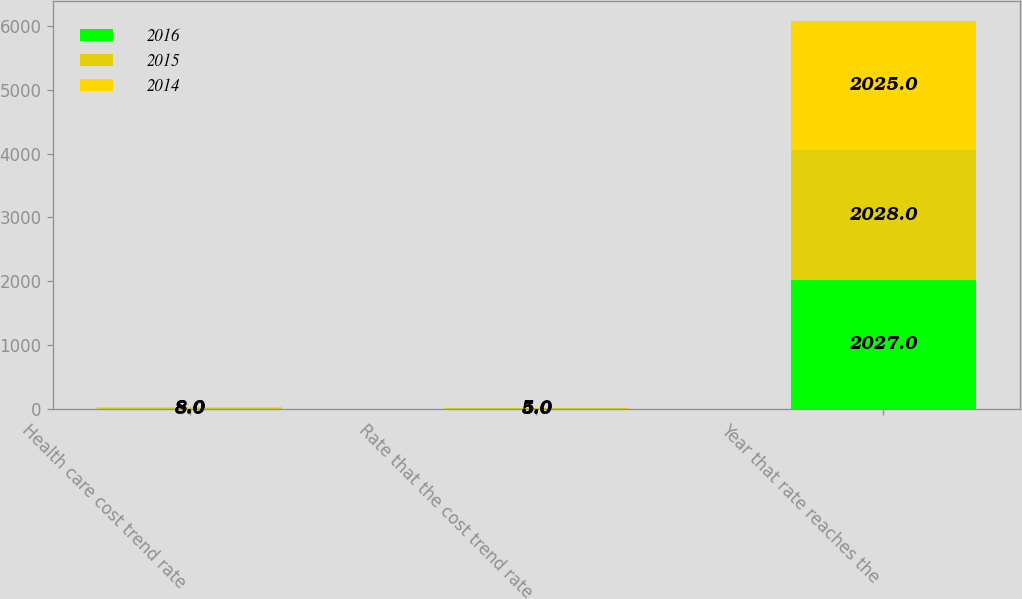Convert chart to OTSL. <chart><loc_0><loc_0><loc_500><loc_500><stacked_bar_chart><ecel><fcel>Health care cost trend rate<fcel>Rate that the cost trend rate<fcel>Year that rate reaches the<nl><fcel>2016<fcel>8<fcel>5<fcel>2027<nl><fcel>2015<fcel>8<fcel>5<fcel>2028<nl><fcel>2014<fcel>8<fcel>5<fcel>2025<nl></chart> 